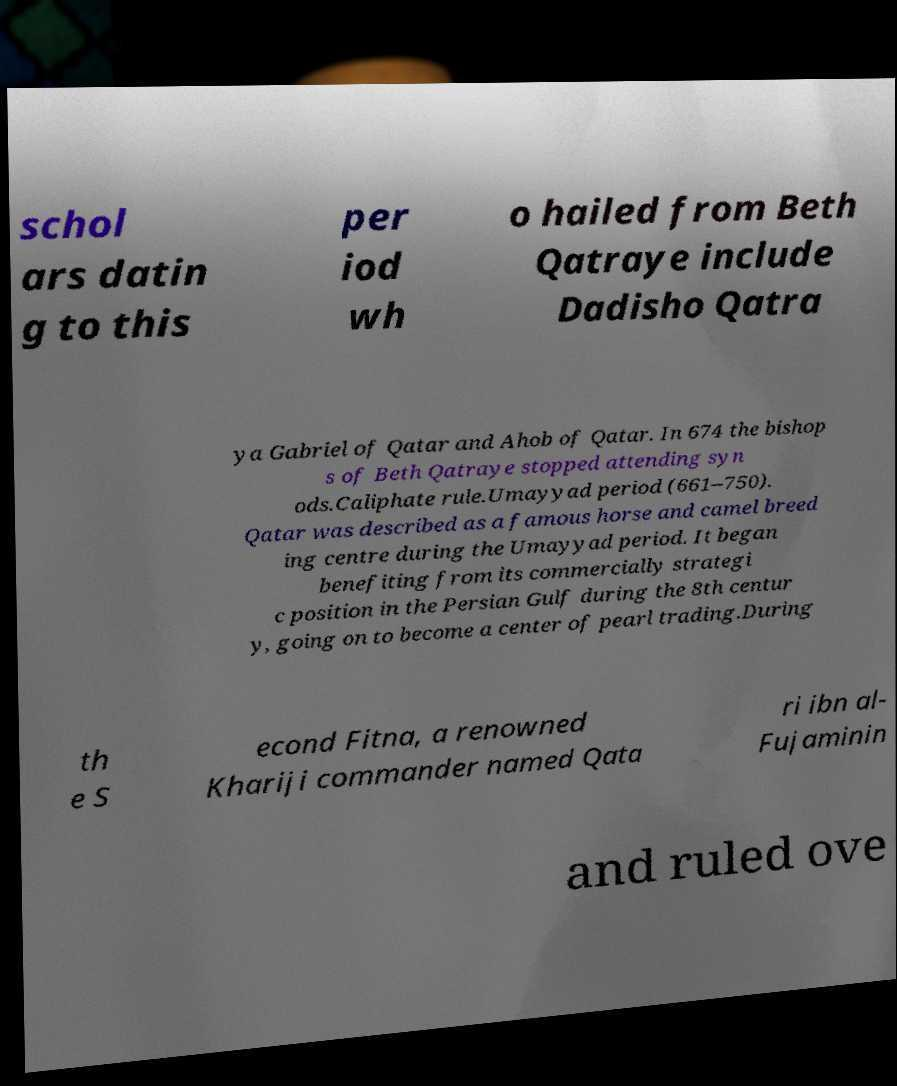Can you read and provide the text displayed in the image?This photo seems to have some interesting text. Can you extract and type it out for me? schol ars datin g to this per iod wh o hailed from Beth Qatraye include Dadisho Qatra ya Gabriel of Qatar and Ahob of Qatar. In 674 the bishop s of Beth Qatraye stopped attending syn ods.Caliphate rule.Umayyad period (661–750). Qatar was described as a famous horse and camel breed ing centre during the Umayyad period. It began benefiting from its commercially strategi c position in the Persian Gulf during the 8th centur y, going on to become a center of pearl trading.During th e S econd Fitna, a renowned Khariji commander named Qata ri ibn al- Fujaminin and ruled ove 